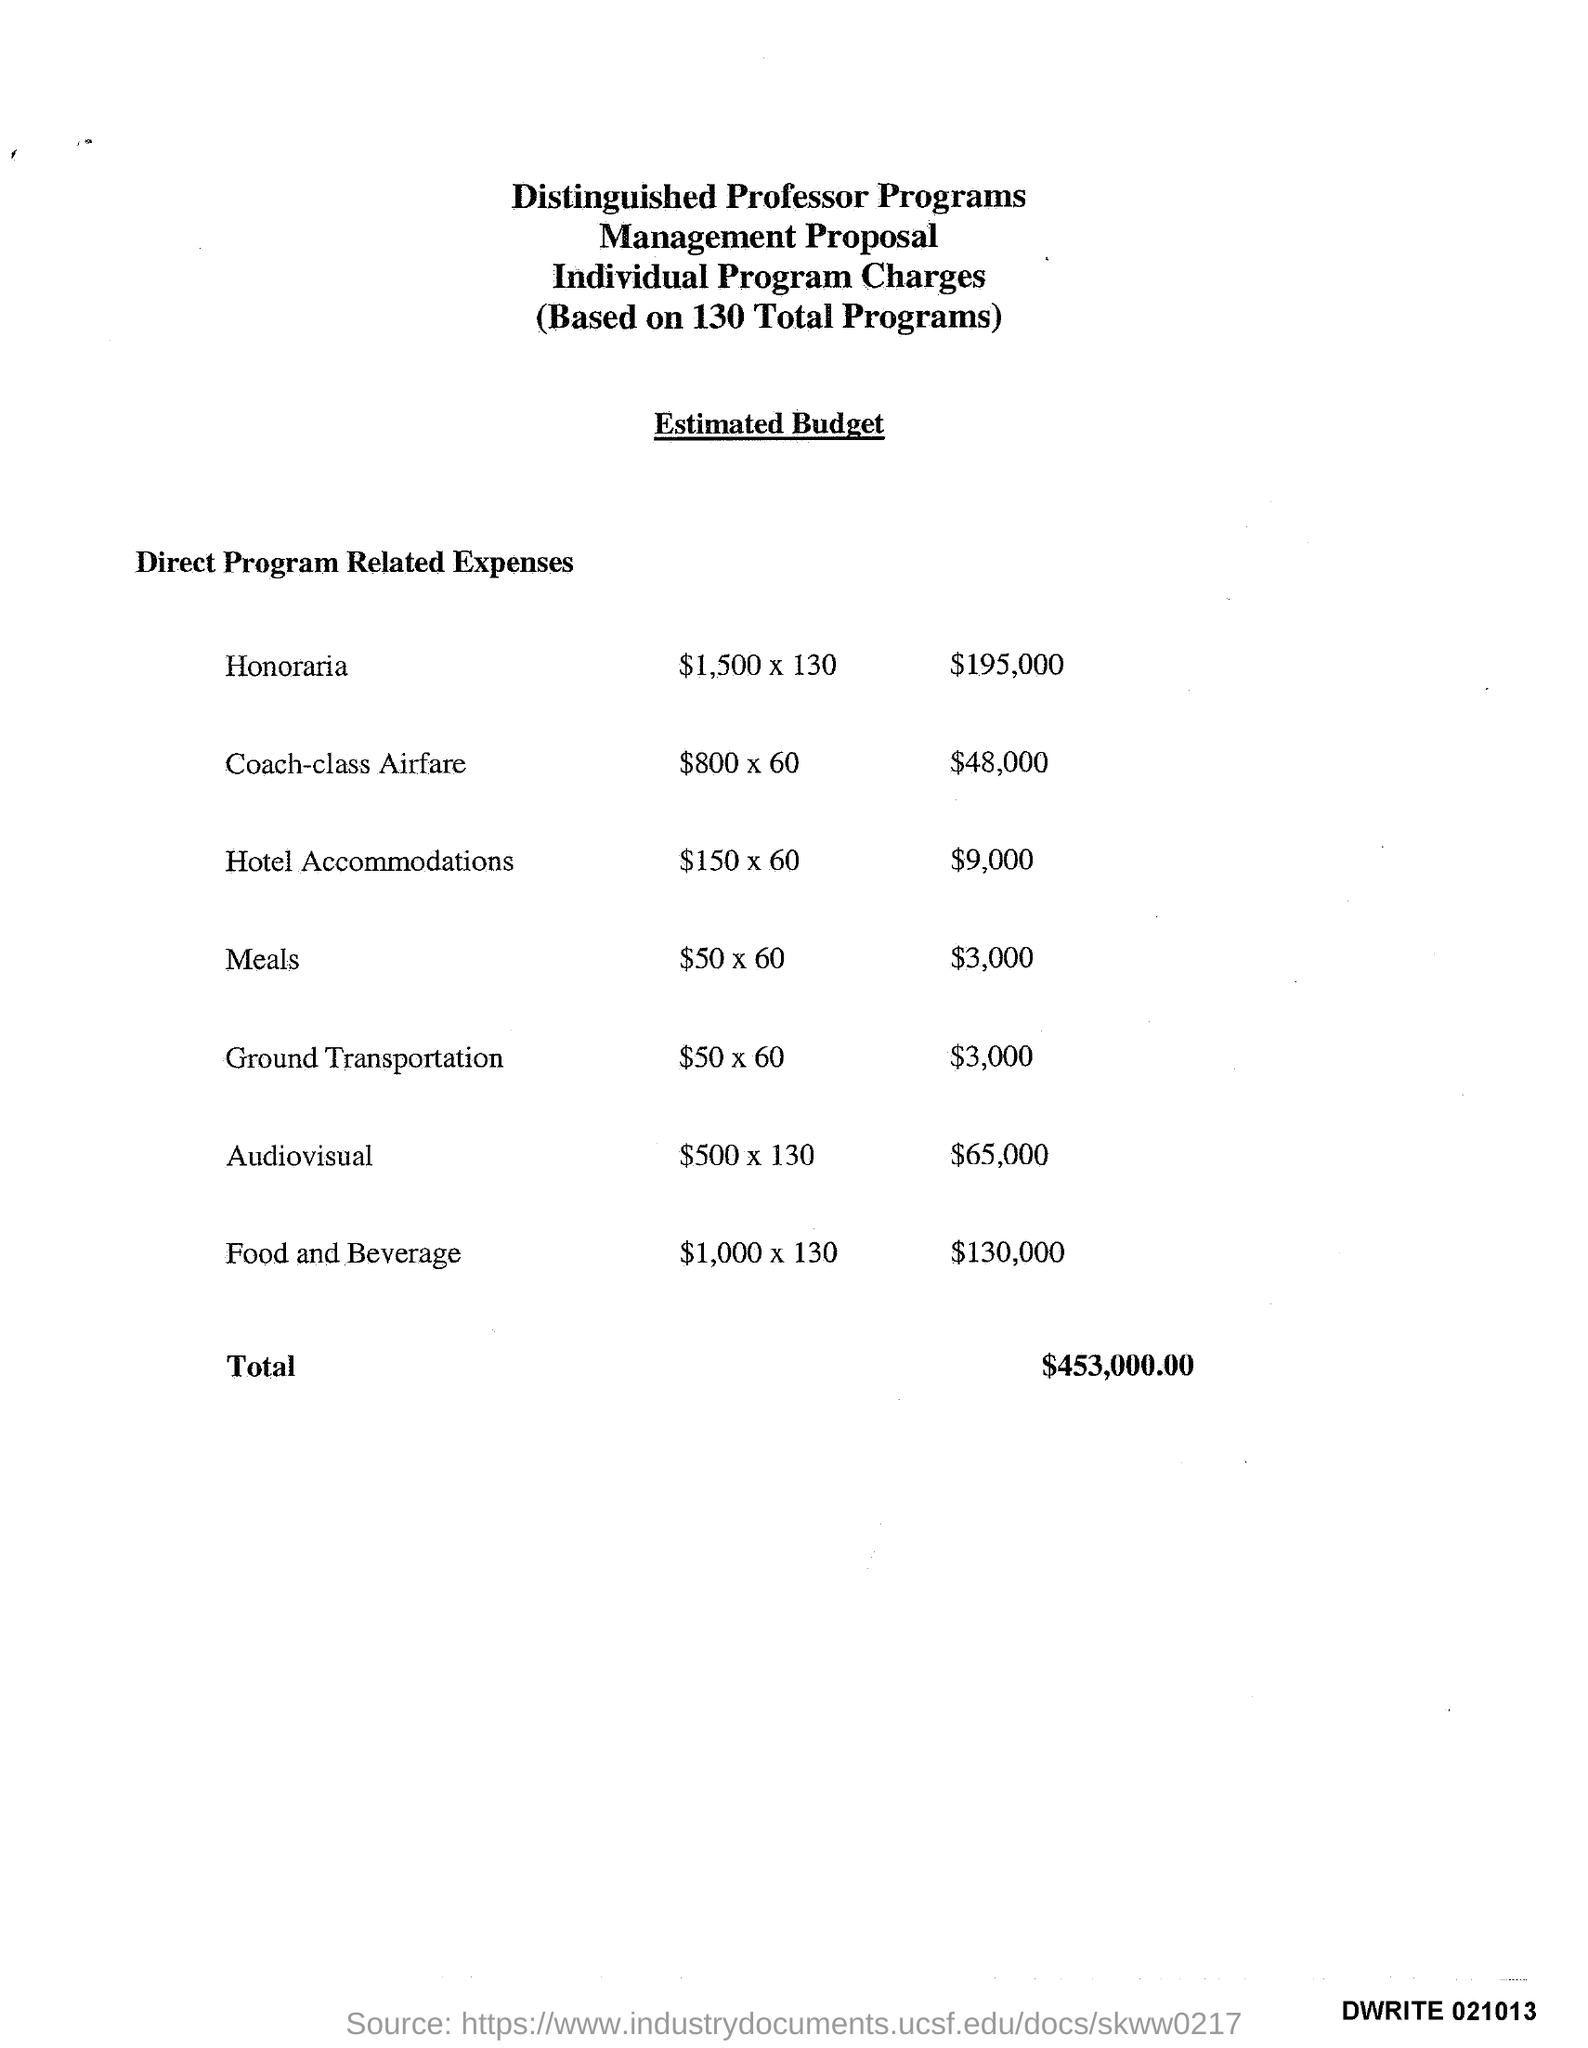Can you break down the 'Audiovisual' expenses? The 'Audiovisual' costs total $65,000, which covers the audiovisual needs for all 130 programs. It averages to about $500 per program. How does this compare to the 'Ground Transportation' budget? The 'Ground Transportation' budget is much lower at $3,000 total. This averages to about $50 per program, significantly less than the 'Audiovisual' expenses. 